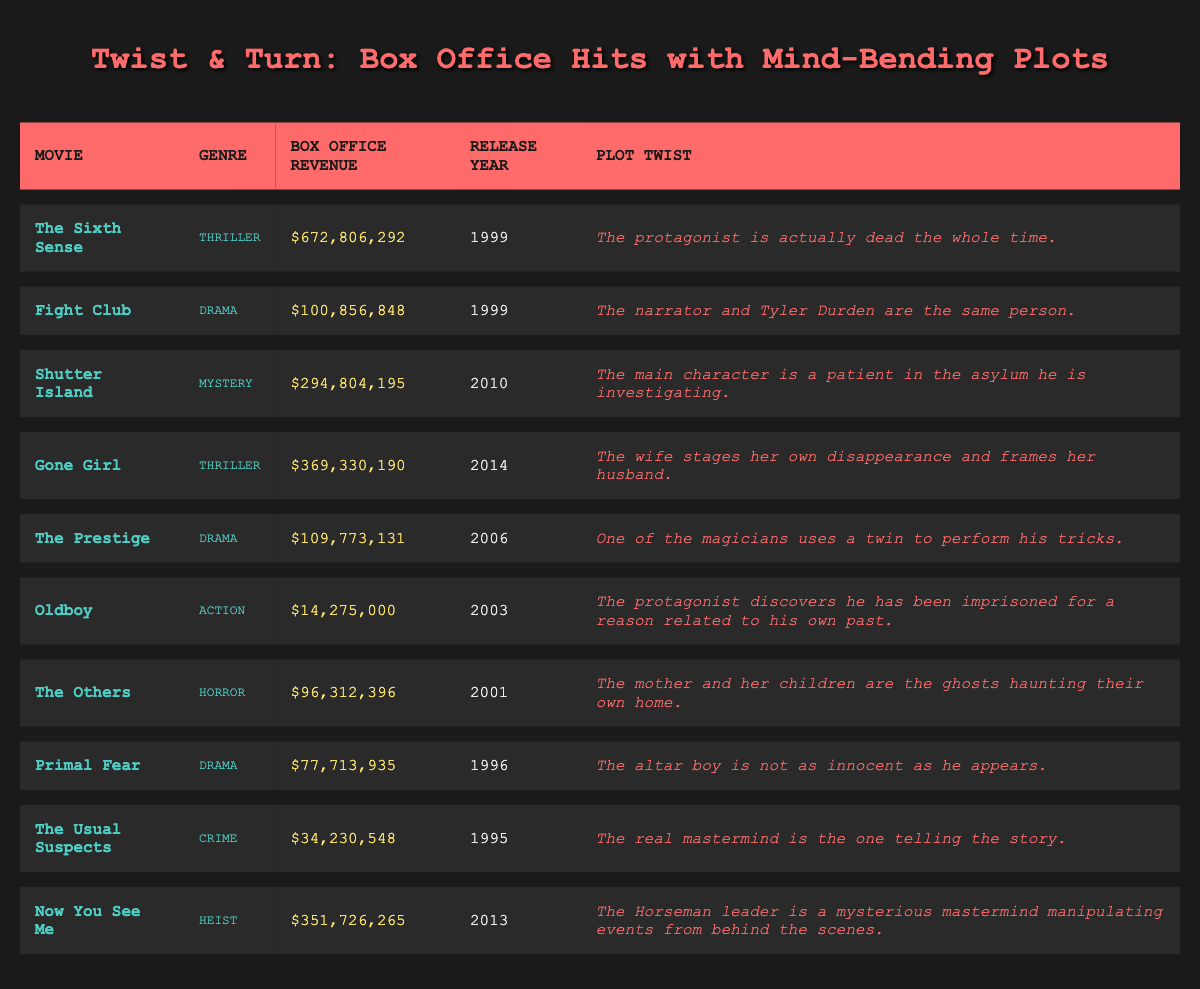What is the highest box office revenue among the movies listed? Looking at the "Box Office Revenue" column, the highest value is $672,806,292, which corresponds to "The Sixth Sense."
Answer: $672,806,292 Which genre has the most movies listed in the table? By counting the movies under each genre, Thriller has 2 movies ("The Sixth Sense" and "Gone Girl"), Drama has 3 movies, Mystery has 1 movie, Action has 1 movie, Horror has 1 movie, Crime has 1 movie, and Heist has 1 movie. The genre with the most movies is Drama.
Answer: Drama What was the box office revenue of "Gone Girl"? The box office revenue for "Gone Girl" is listed in the corresponding row and is $369,330,190.
Answer: $369,330,190 How much higher is "Shutter Island's" box office revenue than "Oldboy's"? The box office revenue for "Shutter Island" is $294,804,195, and for "Oldboy," it is $14,275,000. The difference is $294,804,195 - $14,275,000 = $280,529,195.
Answer: $280,529,195 Is "The Others" the only horror film listed in the table? There is only one entry for the genre Horror in the table, which is "The Others." Therefore, it is indeed the only horror film listed.
Answer: Yes What is the average box office revenue of the Drama genre? The box office revenues for the three Drama movies are $100,856,848 (Fight Club), $109,773,131 (The Prestige), and $77,713,935 (Primal Fear). Adding them gives $100,856,848 + $109,773,131 + $77,713,935 = $288,343,914. Dividing by 3 (the number of Drama films) gives an average of $288,343,914 / 3 = $96,114,638.
Answer: $96,114,638 Which movie's plot twist involves a narrative from the character telling the story? The plot twist of "The Usual Suspects" involves the real mastermind being the one telling the story, as stated in the table.
Answer: The Usual Suspects Which movies released after 2010 have a box office revenue over $300 million? Reviewing the release years and revenue, "Now You See Me" released in 2013 with $351,726,265 fits this criterion, as it is the only movie released after 2010 with revenue over $300 million.
Answer: Now You See Me Which movie has the lowest box office revenue? The lowest box office revenue listed in the table is for "Oldboy," which made $14,275,000.
Answer: Oldboy What percentage of the total box office revenue does "Fight Club" account for? The total box office revenue of all movies is $2,037,467,674. "Fight Club" has a revenue of $100,856,848. To find the percentage: ($100,856,848 / $2,037,467,674) * 100 = 4.94%.
Answer: 4.94% 